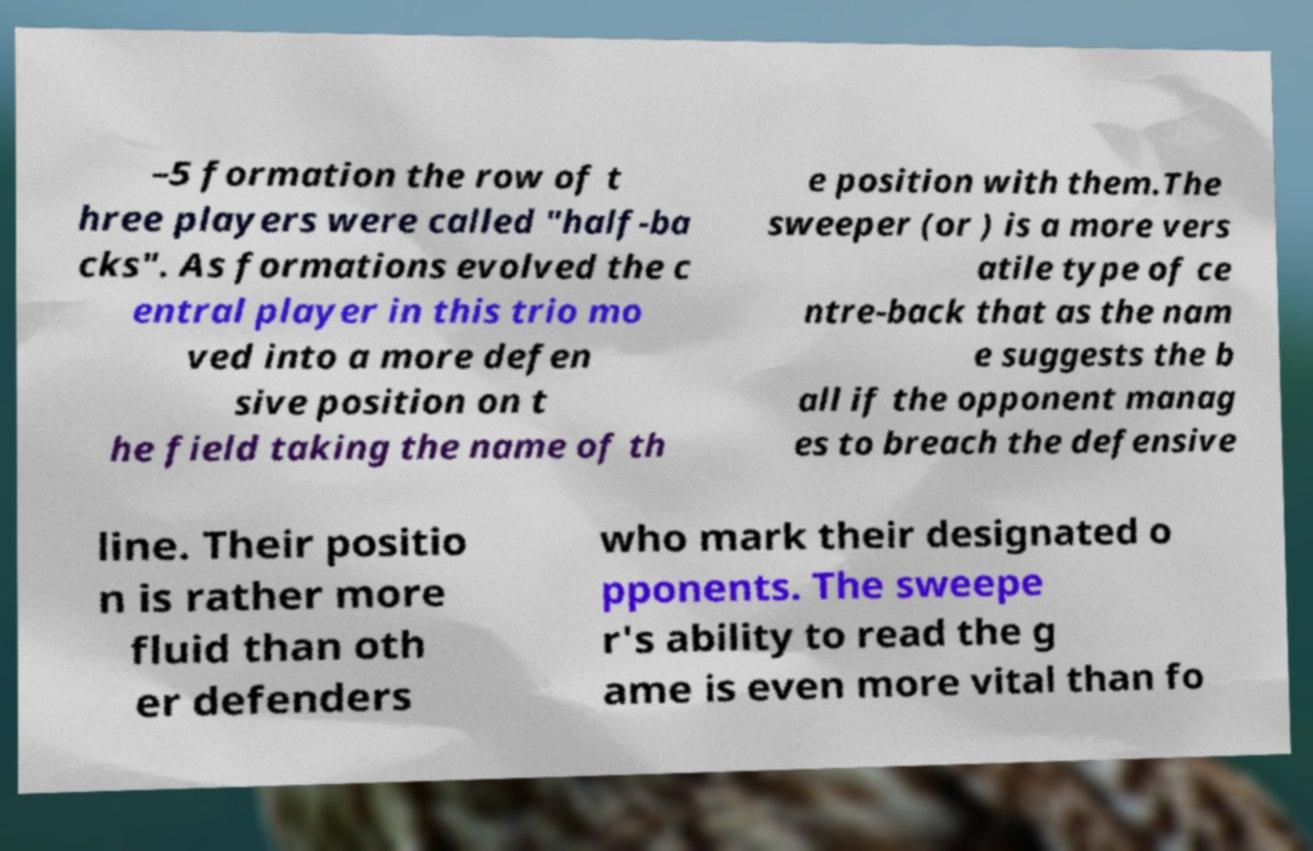Please read and relay the text visible in this image. What does it say? –5 formation the row of t hree players were called "half-ba cks". As formations evolved the c entral player in this trio mo ved into a more defen sive position on t he field taking the name of th e position with them.The sweeper (or ) is a more vers atile type of ce ntre-back that as the nam e suggests the b all if the opponent manag es to breach the defensive line. Their positio n is rather more fluid than oth er defenders who mark their designated o pponents. The sweepe r's ability to read the g ame is even more vital than fo 